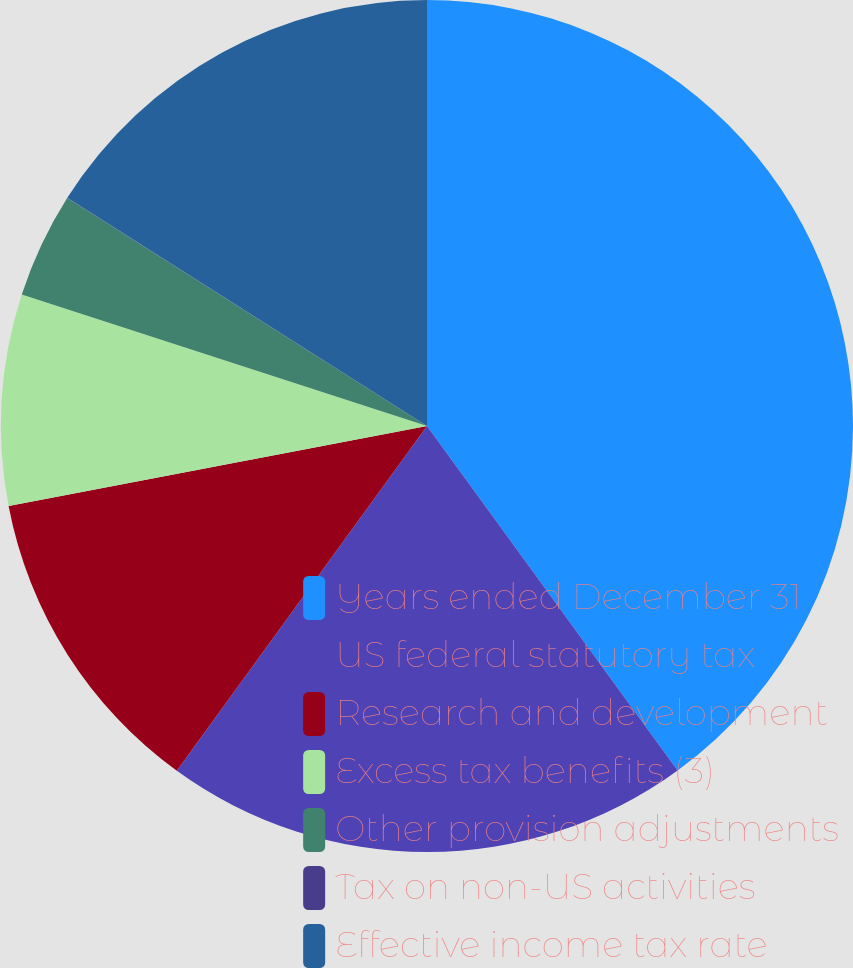<chart> <loc_0><loc_0><loc_500><loc_500><pie_chart><fcel>Years ended December 31<fcel>US federal statutory tax<fcel>Research and development<fcel>Excess tax benefits (3)<fcel>Other provision adjustments<fcel>Tax on non-US activities<fcel>Effective income tax rate<nl><fcel>39.99%<fcel>20.0%<fcel>12.0%<fcel>8.0%<fcel>4.0%<fcel>0.01%<fcel>16.0%<nl></chart> 